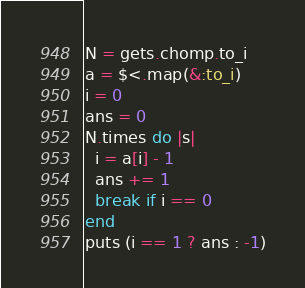<code> <loc_0><loc_0><loc_500><loc_500><_Ruby_>N = gets.chomp.to_i
a = $<.map(&:to_i)
i = 0
ans = 0
N.times do |s|
  i = a[i] - 1
  ans += 1
  break if i == 0
end
puts (i == 1 ? ans : -1)
</code> 